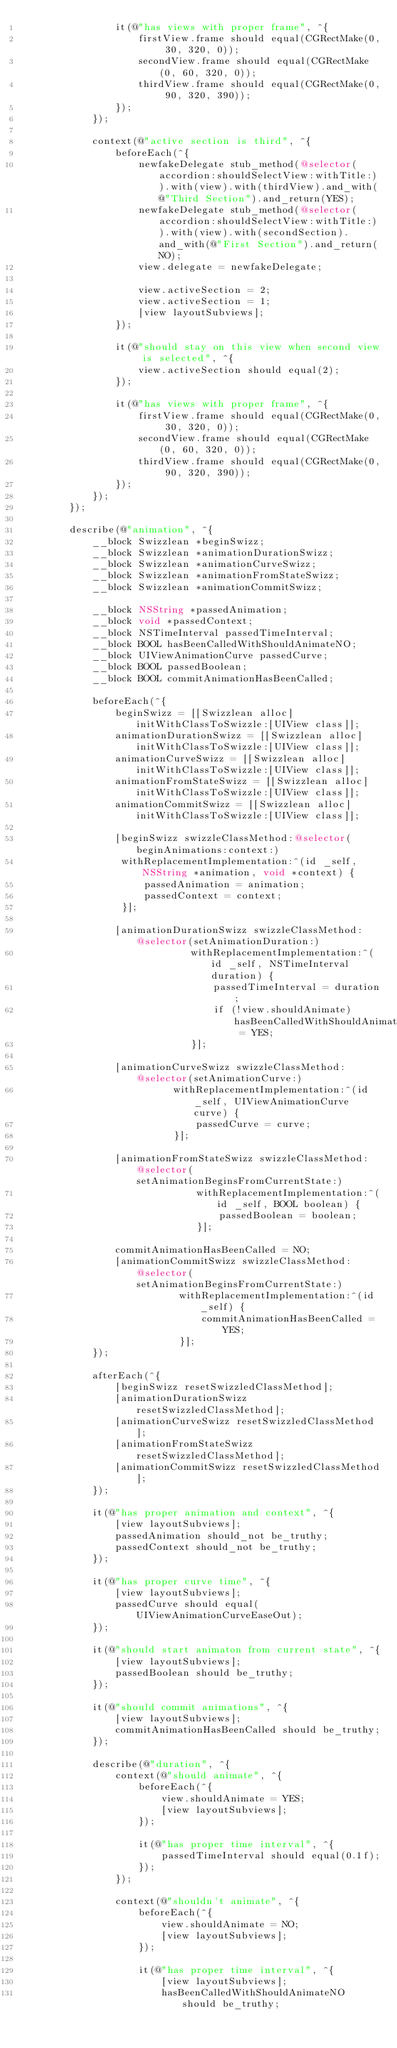Convert code to text. <code><loc_0><loc_0><loc_500><loc_500><_ObjectiveC_>                it(@"has views with proper frame", ^{
                    firstView.frame should equal(CGRectMake(0, 30, 320, 0));
                    secondView.frame should equal(CGRectMake(0, 60, 320, 0));
                    thirdView.frame should equal(CGRectMake(0, 90, 320, 390));
                });
            });
            
            context(@"active section is third", ^{
                beforeEach(^{
                    newfakeDelegate stub_method(@selector(accordion:shouldSelectView:withTitle:)).with(view).with(thirdView).and_with(@"Third Section").and_return(YES);
                    newfakeDelegate stub_method(@selector(accordion:shouldSelectView:withTitle:)).with(view).with(secondSection).and_with(@"First Section").and_return(NO);
                    view.delegate = newfakeDelegate;
                    
                    view.activeSection = 2;
                    view.activeSection = 1;
                    [view layoutSubviews];
                });
                
                it(@"should stay on this view when second view is selected", ^{
                    view.activeSection should equal(2);
                });
                
                it(@"has views with proper frame", ^{
                    firstView.frame should equal(CGRectMake(0, 30, 320, 0));
                    secondView.frame should equal(CGRectMake(0, 60, 320, 0));
                    thirdView.frame should equal(CGRectMake(0, 90, 320, 390));
                });
            });
        });
        
        describe(@"animation", ^{
            __block Swizzlean *beginSwizz;
            __block Swizzlean *animationDurationSwizz;
            __block Swizzlean *animationCurveSwizz;
            __block Swizzlean *animationFromStateSwizz;
            __block Swizzlean *animationCommitSwizz;
            
            __block NSString *passedAnimation;
            __block void *passedContext;
            __block NSTimeInterval passedTimeInterval;
            __block BOOL hasBeenCalledWithShouldAnimateNO;
            __block UIViewAnimationCurve passedCurve;
            __block BOOL passedBoolean;
            __block BOOL commitAnimationHasBeenCalled;
            
            beforeEach(^{
                beginSwizz = [[Swizzlean alloc] initWithClassToSwizzle:[UIView class]];
                animationDurationSwizz = [[Swizzlean alloc] initWithClassToSwizzle:[UIView class]];
                animationCurveSwizz = [[Swizzlean alloc] initWithClassToSwizzle:[UIView class]];
                animationFromStateSwizz = [[Swizzlean alloc] initWithClassToSwizzle:[UIView class]];
                animationCommitSwizz = [[Swizzlean alloc] initWithClassToSwizzle:[UIView class]];
                
                [beginSwizz swizzleClassMethod:@selector(beginAnimations:context:)
                 withReplacementImplementation:^(id _self, NSString *animation, void *context) {
                     passedAnimation = animation;
                     passedContext = context;
                 }];
                
                [animationDurationSwizz swizzleClassMethod:@selector(setAnimationDuration:)
                             withReplacementImplementation:^(id _self, NSTimeInterval duration) {
                                 passedTimeInterval = duration;
                                 if (!view.shouldAnimate) hasBeenCalledWithShouldAnimateNO = YES;
                             }];
                
                [animationCurveSwizz swizzleClassMethod:@selector(setAnimationCurve:)
                          withReplacementImplementation:^(id _self, UIViewAnimationCurve curve) {
                              passedCurve = curve;
                          }];
                
                [animationFromStateSwizz swizzleClassMethod:@selector(setAnimationBeginsFromCurrentState:)
                              withReplacementImplementation:^(id _self, BOOL boolean) {
                                  passedBoolean = boolean;
                              }];
                
                commitAnimationHasBeenCalled = NO;
                [animationCommitSwizz swizzleClassMethod:@selector(setAnimationBeginsFromCurrentState:)
                           withReplacementImplementation:^(id _self) {
                               commitAnimationHasBeenCalled = YES;
                           }];
            });
            
            afterEach(^{
                [beginSwizz resetSwizzledClassMethod];
                [animationDurationSwizz resetSwizzledClassMethod];
                [animationCurveSwizz resetSwizzledClassMethod];
                [animationFromStateSwizz resetSwizzledClassMethod];
                [animationCommitSwizz resetSwizzledClassMethod];
            });
            
            it(@"has proper animation and context", ^{
                [view layoutSubviews];
                passedAnimation should_not be_truthy;
                passedContext should_not be_truthy;
            });
            
            it(@"has proper curve time", ^{
                [view layoutSubviews];
                passedCurve should equal(UIViewAnimationCurveEaseOut);
            });
            
            it(@"should start animaton from current state", ^{
                [view layoutSubviews];
                passedBoolean should be_truthy;
            });
            
            it(@"should commit animations", ^{
                [view layoutSubviews];
                commitAnimationHasBeenCalled should be_truthy;
            });
            
            describe(@"duration", ^{
                context(@"should animate", ^{
                    beforeEach(^{
                        view.shouldAnimate = YES;
                        [view layoutSubviews];
                    });
                    
                    it(@"has proper time interval", ^{
                        passedTimeInterval should equal(0.1f);
                    });
                });
                
                context(@"shouldn't animate", ^{
                    beforeEach(^{
                        view.shouldAnimate = NO;
                        [view layoutSubviews];
                    });
                    
                    it(@"has proper time interval", ^{
                        [view layoutSubviews];
                        hasBeenCalledWithShouldAnimateNO should be_truthy;</code> 